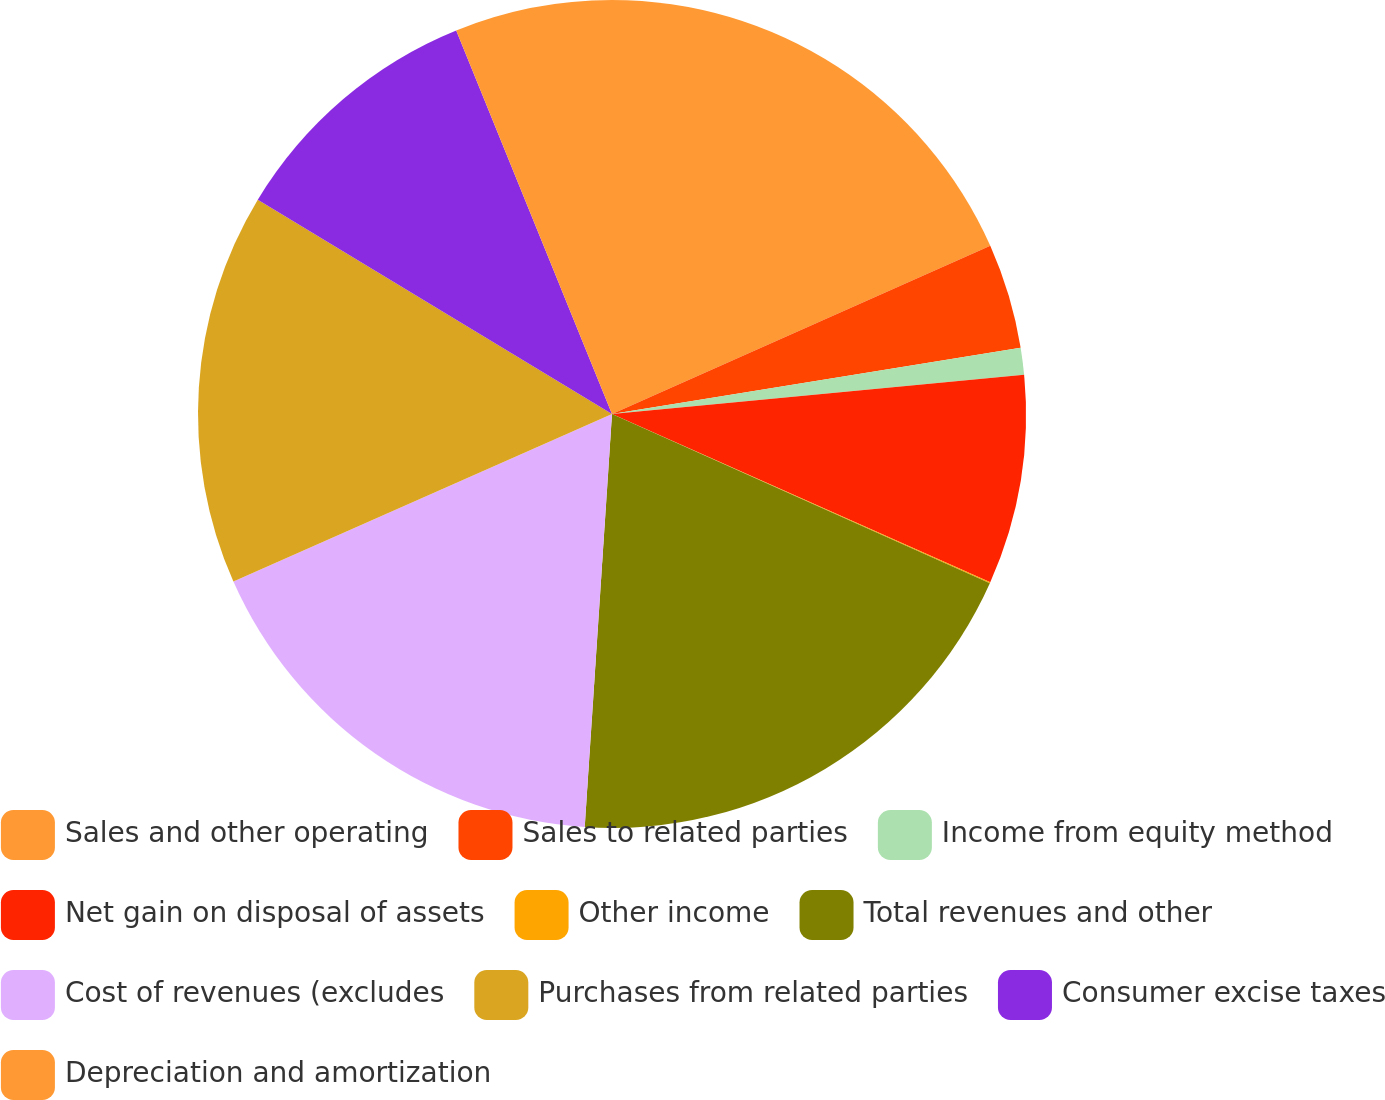Convert chart to OTSL. <chart><loc_0><loc_0><loc_500><loc_500><pie_chart><fcel>Sales and other operating<fcel>Sales to related parties<fcel>Income from equity method<fcel>Net gain on disposal of assets<fcel>Other income<fcel>Total revenues and other<fcel>Cost of revenues (excludes<fcel>Purchases from related parties<fcel>Consumer excise taxes<fcel>Depreciation and amortization<nl><fcel>18.34%<fcel>4.1%<fcel>1.05%<fcel>8.17%<fcel>0.04%<fcel>19.35%<fcel>17.32%<fcel>15.29%<fcel>10.2%<fcel>6.14%<nl></chart> 